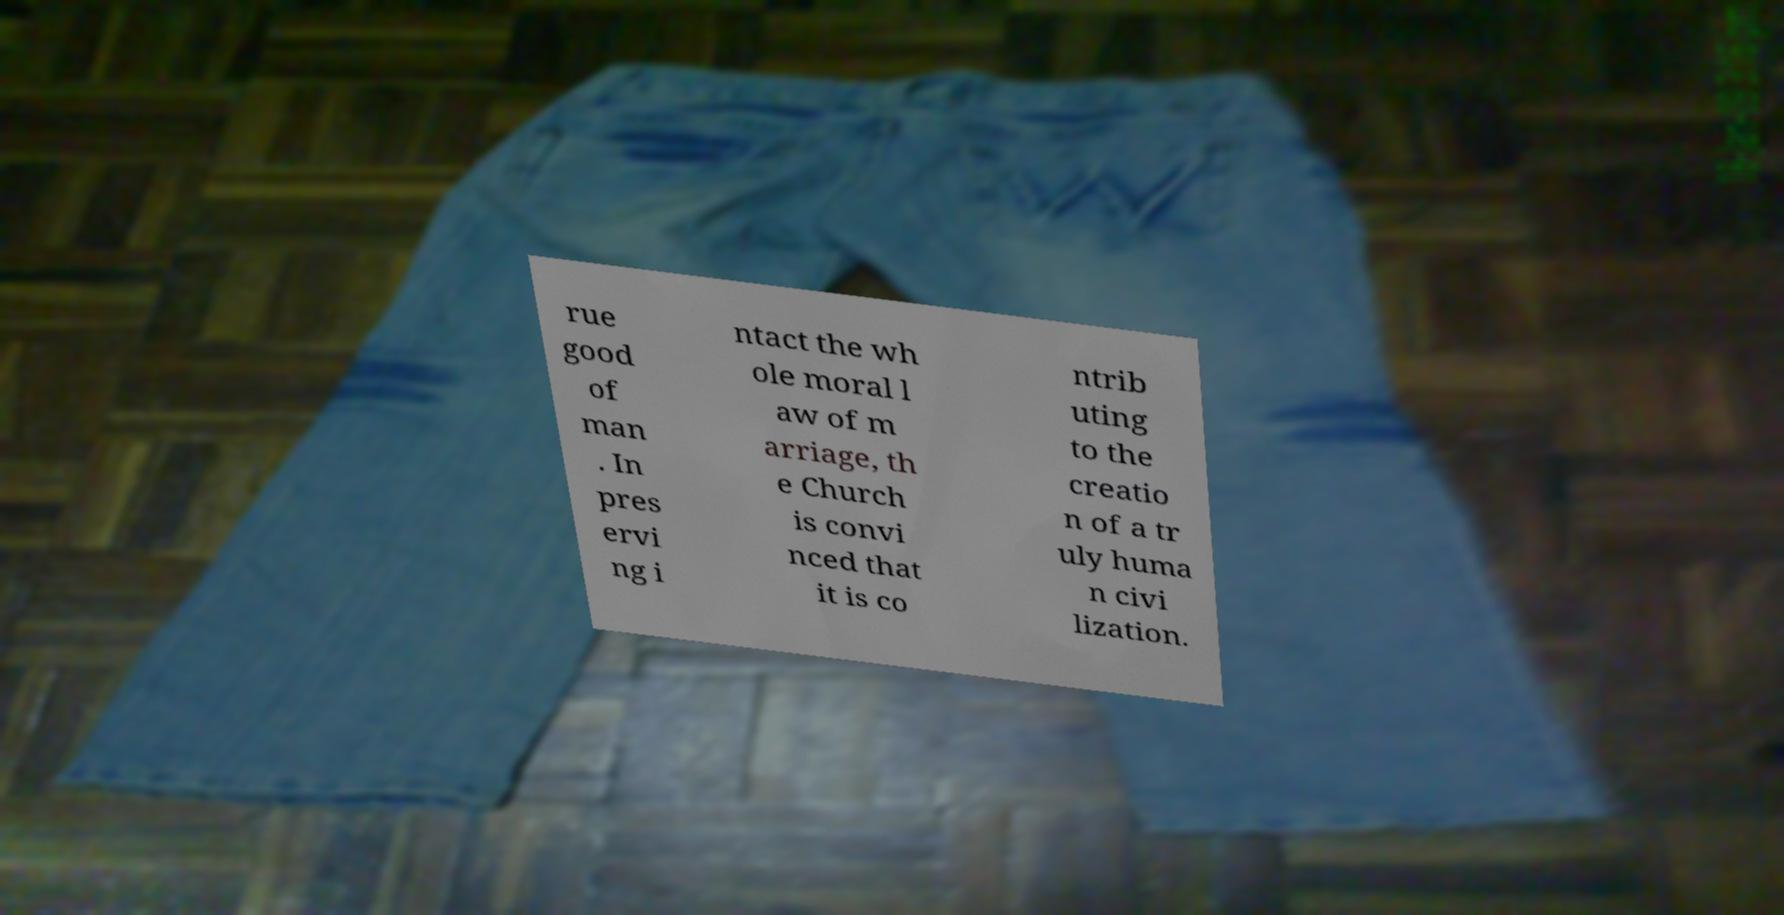Could you extract and type out the text from this image? rue good of man . In pres ervi ng i ntact the wh ole moral l aw of m arriage, th e Church is convi nced that it is co ntrib uting to the creatio n of a tr uly huma n civi lization. 